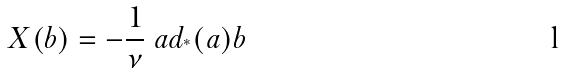Convert formula to latex. <formula><loc_0><loc_0><loc_500><loc_500>X ( b ) = - \frac { 1 } { \nu } \ a d _ { ^ { * } } ( a ) b</formula> 